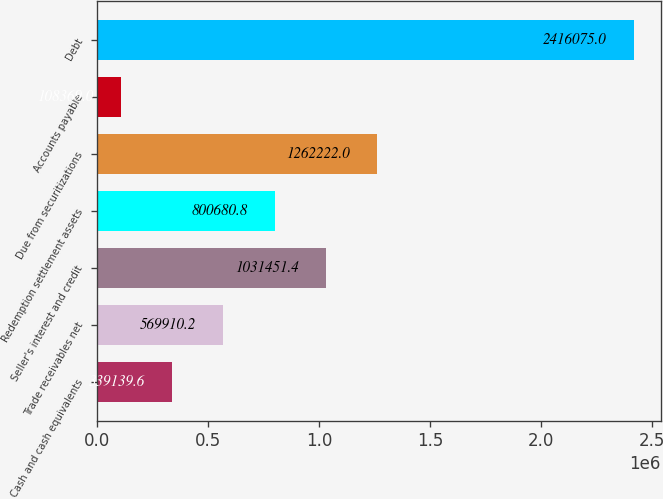<chart> <loc_0><loc_0><loc_500><loc_500><bar_chart><fcel>Cash and cash equivalents<fcel>Trade receivables net<fcel>Seller's interest and credit<fcel>Redemption settlement assets<fcel>Due from securitizations<fcel>Accounts payable<fcel>Debt<nl><fcel>339140<fcel>569910<fcel>1.03145e+06<fcel>800681<fcel>1.26222e+06<fcel>108369<fcel>2.41608e+06<nl></chart> 